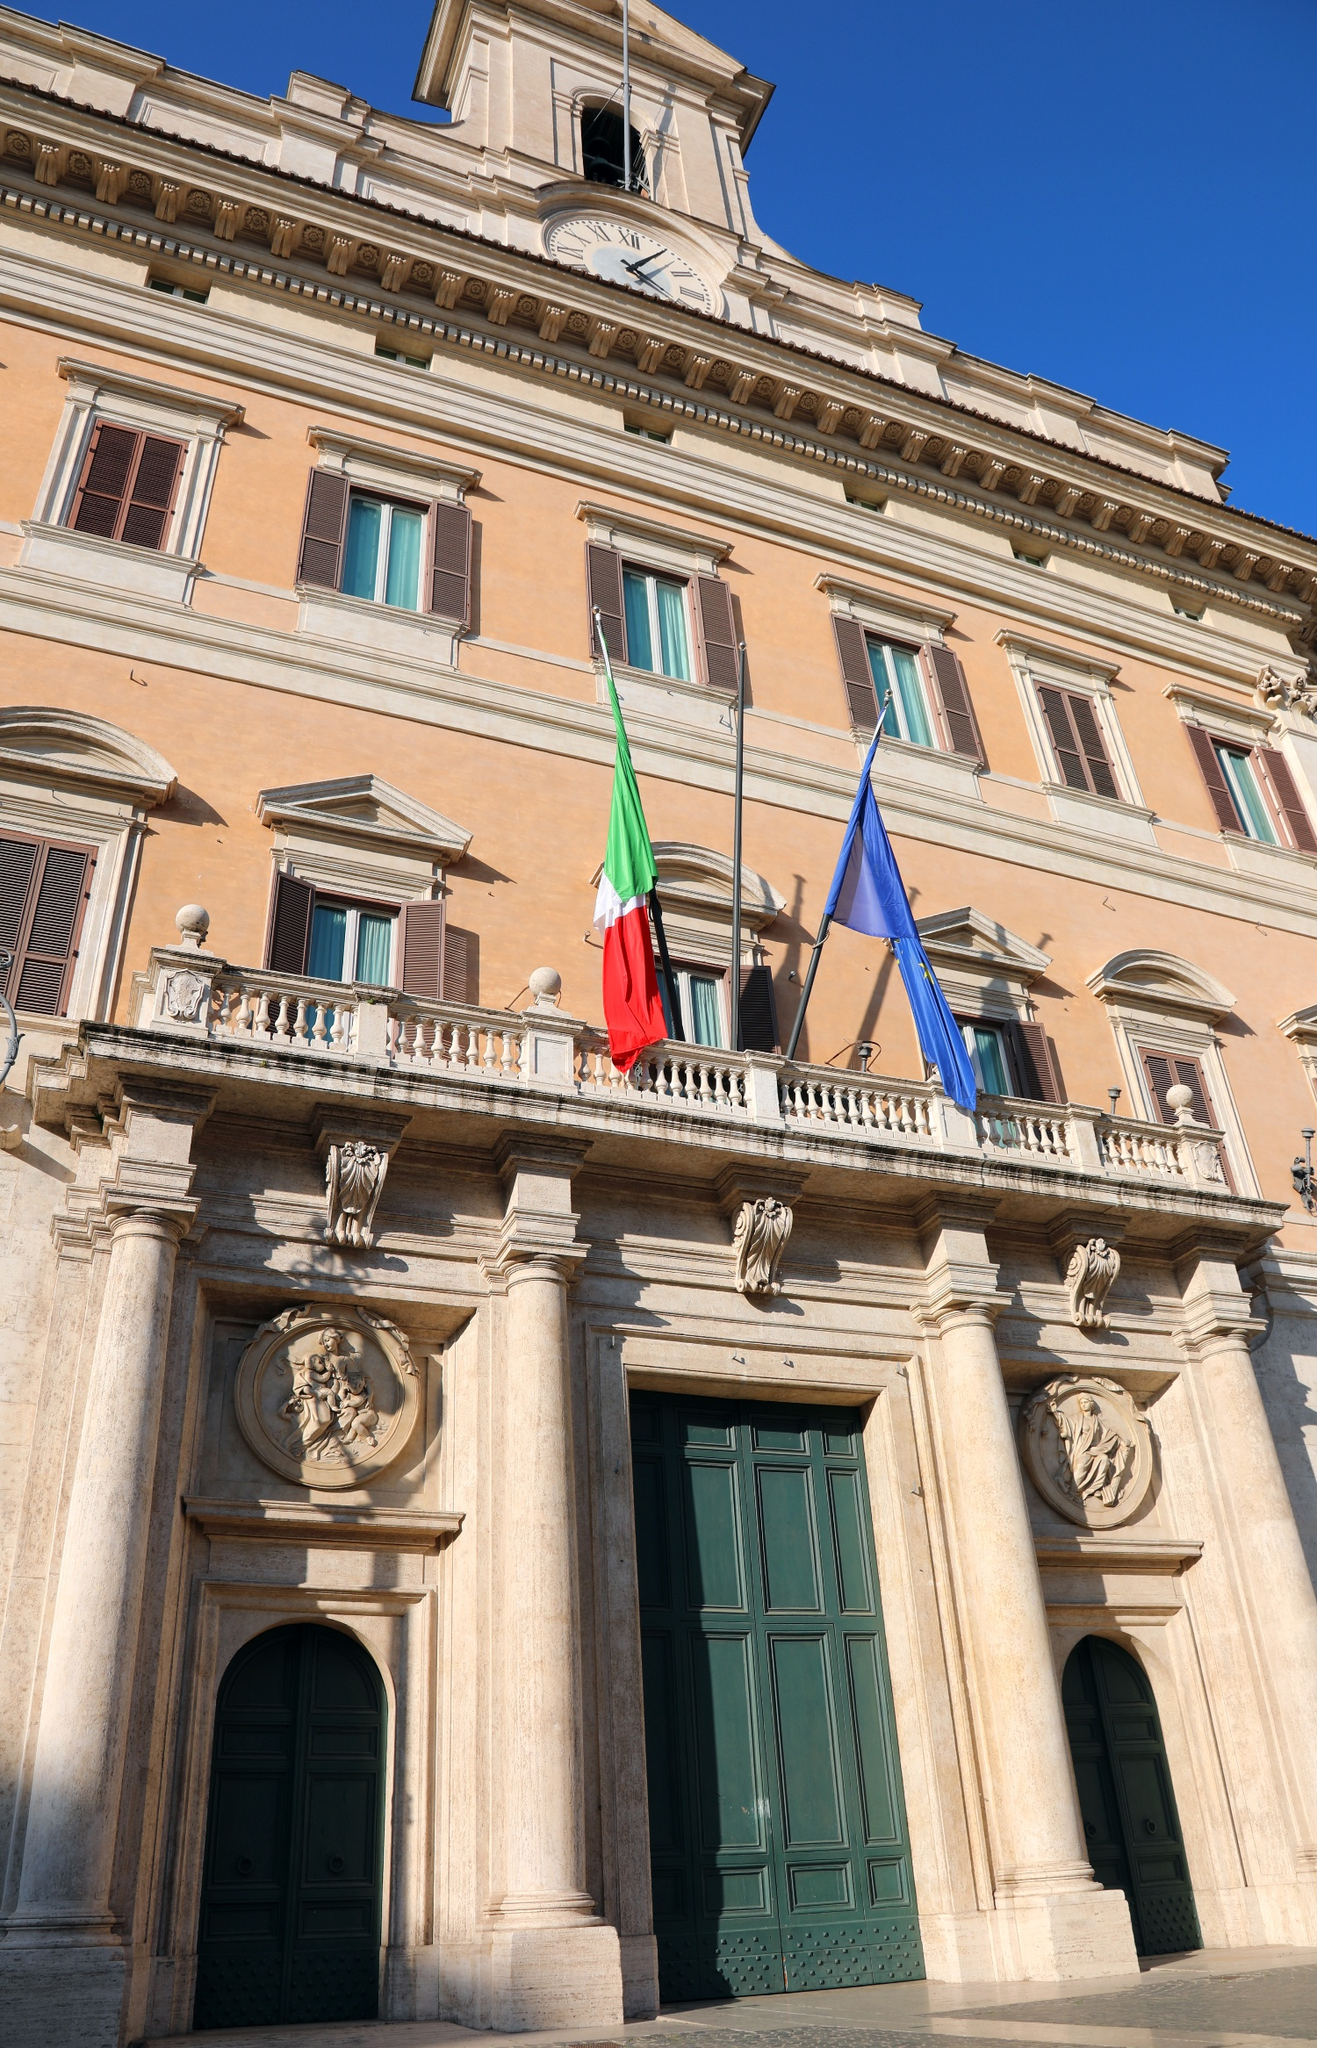Analyze the image in a comprehensive and detailed manner. The image vividly captures the Palazzo Montecitorio, prominently located in Rome, Italy, and serving as the seat of the Italian Chamber of Deputies. The building's facade is a rich palette of pale orange and white, struck by the sunlight that enhances its grandeur. This Baroque-style architecture, designed by the architect Ernesto Basile, is noticeable for its harmonious proportions and elaborate decorations including pilasters, cornices, and a striking clock tower that oversees the surroundings. The Italian and European Union flags wave proudly in the breeze, symbolizing Italy's national pride and its role within the EU. This perspective invites an appreciation of the building's role in Italian politics as well as its architectural beauty. 